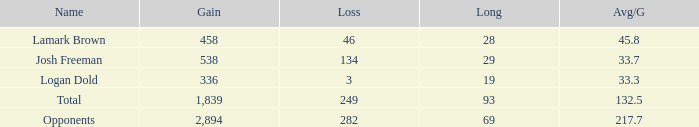Could you parse the entire table? {'header': ['Name', 'Gain', 'Loss', 'Long', 'Avg/G'], 'rows': [['Lamark Brown', '458', '46', '28', '45.8'], ['Josh Freeman', '538', '134', '29', '33.7'], ['Logan Dold', '336', '3', '19', '33.3'], ['Total', '1,839', '249', '93', '132.5'], ['Opponents', '2,894', '282', '69', '217.7']]} Which Avg/G has a Gain of 1,839? 132.5. 